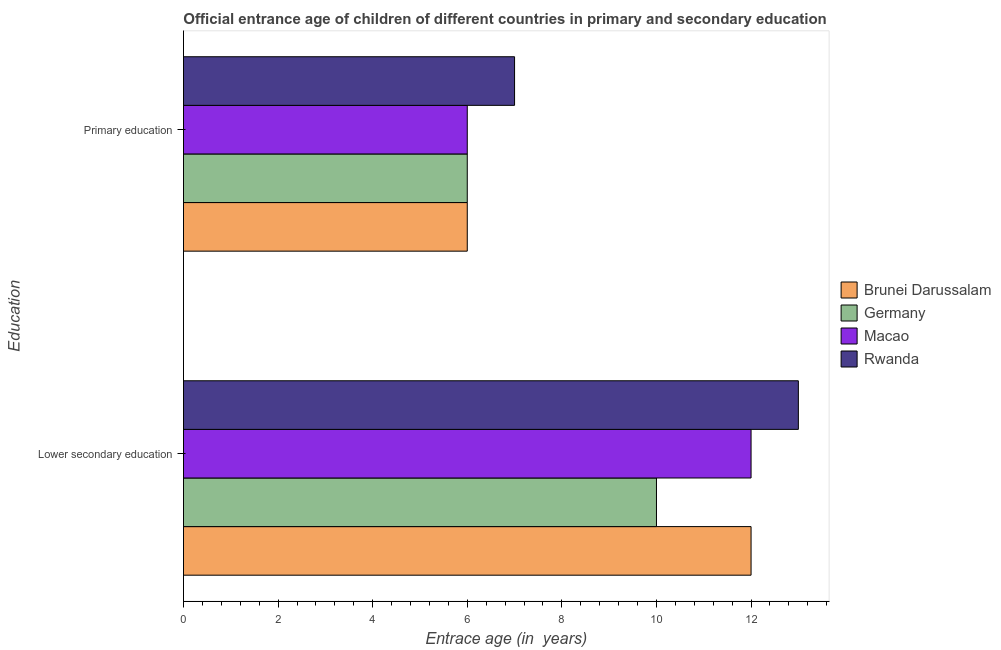How many different coloured bars are there?
Offer a terse response. 4. How many groups of bars are there?
Provide a succinct answer. 2. How many bars are there on the 2nd tick from the bottom?
Your answer should be compact. 4. What is the label of the 2nd group of bars from the top?
Provide a short and direct response. Lower secondary education. Across all countries, what is the maximum entrance age of children in lower secondary education?
Provide a short and direct response. 13. Across all countries, what is the minimum entrance age of children in lower secondary education?
Your response must be concise. 10. In which country was the entrance age of chiildren in primary education maximum?
Provide a short and direct response. Rwanda. What is the total entrance age of chiildren in primary education in the graph?
Keep it short and to the point. 25. What is the difference between the entrance age of children in lower secondary education in Macao and that in Rwanda?
Your response must be concise. -1. What is the difference between the entrance age of chiildren in primary education in Germany and the entrance age of children in lower secondary education in Macao?
Keep it short and to the point. -6. What is the average entrance age of chiildren in primary education per country?
Offer a terse response. 6.25. What is the difference between the entrance age of chiildren in primary education and entrance age of children in lower secondary education in Germany?
Provide a short and direct response. -4. In how many countries, is the entrance age of children in lower secondary education greater than 0.8 years?
Offer a very short reply. 4. What is the ratio of the entrance age of chiildren in primary education in Macao to that in Rwanda?
Offer a terse response. 0.86. Is the entrance age of chiildren in primary education in Brunei Darussalam less than that in Macao?
Your response must be concise. No. What does the 3rd bar from the top in Primary education represents?
Keep it short and to the point. Germany. What does the 4th bar from the bottom in Primary education represents?
Your answer should be very brief. Rwanda. How many countries are there in the graph?
Ensure brevity in your answer.  4. Are the values on the major ticks of X-axis written in scientific E-notation?
Give a very brief answer. No. Does the graph contain any zero values?
Your answer should be very brief. No. Does the graph contain grids?
Provide a succinct answer. No. Where does the legend appear in the graph?
Ensure brevity in your answer.  Center right. What is the title of the graph?
Ensure brevity in your answer.  Official entrance age of children of different countries in primary and secondary education. What is the label or title of the X-axis?
Your answer should be very brief. Entrace age (in  years). What is the label or title of the Y-axis?
Ensure brevity in your answer.  Education. What is the Entrace age (in  years) of Brunei Darussalam in Lower secondary education?
Your answer should be compact. 12. What is the Entrace age (in  years) of Brunei Darussalam in Primary education?
Your answer should be compact. 6. What is the Entrace age (in  years) of Germany in Primary education?
Ensure brevity in your answer.  6. What is the Entrace age (in  years) of Rwanda in Primary education?
Offer a terse response. 7. Across all Education, what is the maximum Entrace age (in  years) in Brunei Darussalam?
Ensure brevity in your answer.  12. Across all Education, what is the maximum Entrace age (in  years) in Germany?
Ensure brevity in your answer.  10. Across all Education, what is the minimum Entrace age (in  years) in Macao?
Keep it short and to the point. 6. What is the total Entrace age (in  years) of Macao in the graph?
Give a very brief answer. 18. What is the total Entrace age (in  years) in Rwanda in the graph?
Your response must be concise. 20. What is the difference between the Entrace age (in  years) of Brunei Darussalam in Lower secondary education and that in Primary education?
Give a very brief answer. 6. What is the difference between the Entrace age (in  years) in Macao in Lower secondary education and the Entrace age (in  years) in Rwanda in Primary education?
Offer a terse response. 5. What is the average Entrace age (in  years) of Brunei Darussalam per Education?
Keep it short and to the point. 9. What is the average Entrace age (in  years) of Germany per Education?
Give a very brief answer. 8. What is the average Entrace age (in  years) of Macao per Education?
Offer a very short reply. 9. What is the average Entrace age (in  years) in Rwanda per Education?
Ensure brevity in your answer.  10. What is the difference between the Entrace age (in  years) in Brunei Darussalam and Entrace age (in  years) in Germany in Lower secondary education?
Ensure brevity in your answer.  2. What is the difference between the Entrace age (in  years) in Germany and Entrace age (in  years) in Rwanda in Lower secondary education?
Offer a terse response. -3. What is the difference between the Entrace age (in  years) of Macao and Entrace age (in  years) of Rwanda in Lower secondary education?
Provide a succinct answer. -1. What is the difference between the Entrace age (in  years) of Germany and Entrace age (in  years) of Rwanda in Primary education?
Your response must be concise. -1. What is the difference between the Entrace age (in  years) of Macao and Entrace age (in  years) of Rwanda in Primary education?
Your response must be concise. -1. What is the ratio of the Entrace age (in  years) of Brunei Darussalam in Lower secondary education to that in Primary education?
Provide a short and direct response. 2. What is the ratio of the Entrace age (in  years) in Germany in Lower secondary education to that in Primary education?
Provide a short and direct response. 1.67. What is the ratio of the Entrace age (in  years) of Macao in Lower secondary education to that in Primary education?
Your response must be concise. 2. What is the ratio of the Entrace age (in  years) of Rwanda in Lower secondary education to that in Primary education?
Make the answer very short. 1.86. What is the difference between the highest and the second highest Entrace age (in  years) of Rwanda?
Your answer should be very brief. 6. What is the difference between the highest and the lowest Entrace age (in  years) of Brunei Darussalam?
Offer a terse response. 6. 